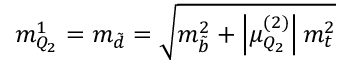Convert formula to latex. <formula><loc_0><loc_0><loc_500><loc_500>m _ { Q _ { 2 } } ^ { 1 } = m _ { \tilde { d } } = \sqrt { m _ { \tilde { b } } ^ { 2 } + \left | \mu _ { Q _ { 2 } } ^ { ( 2 ) } \right | m _ { t } ^ { 2 } }</formula> 